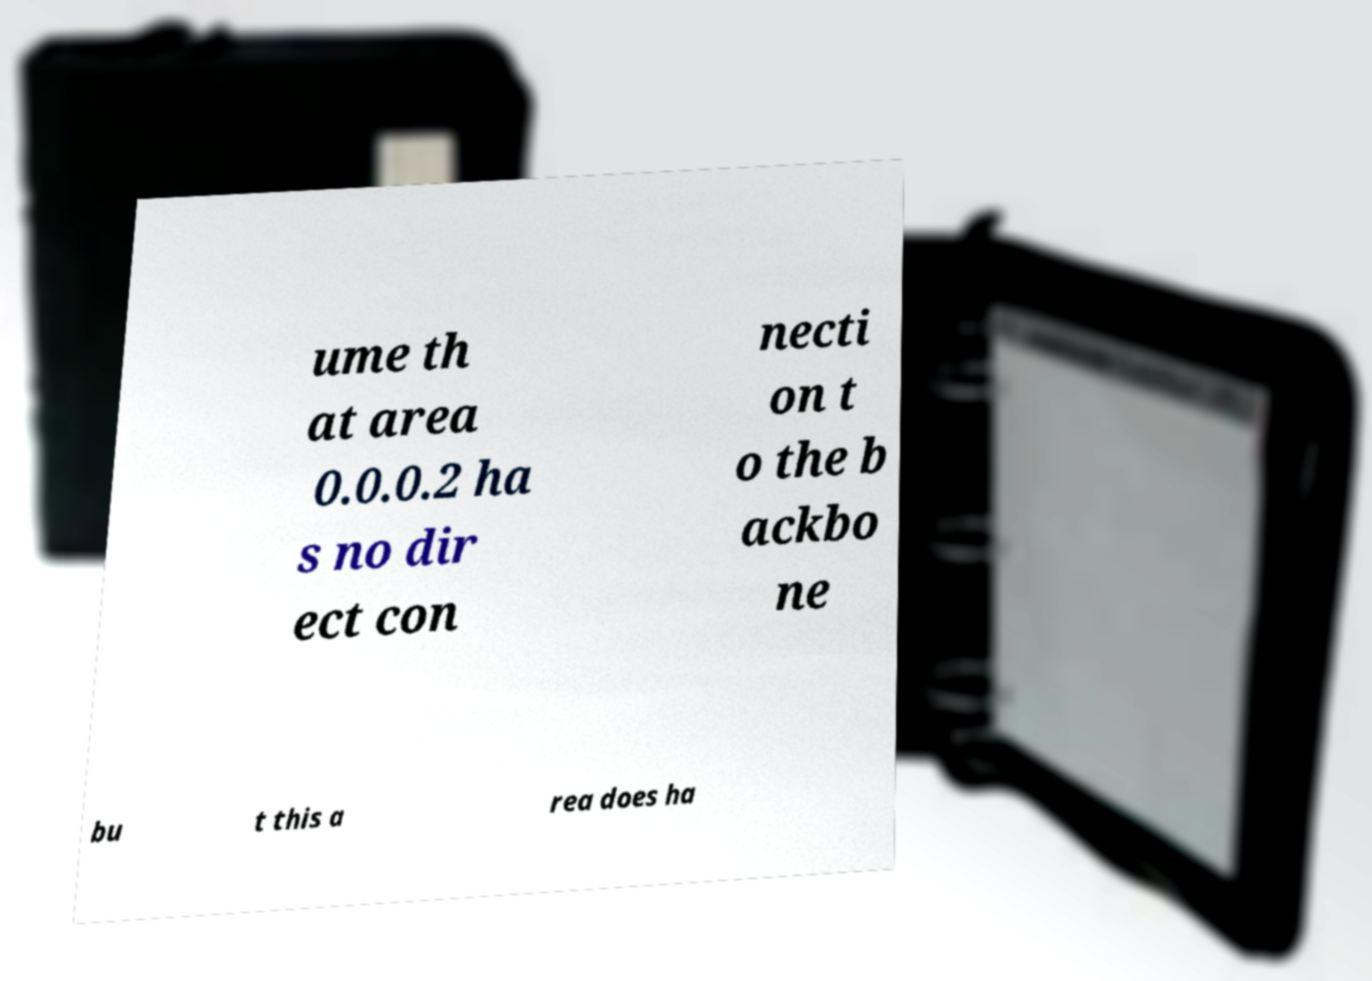Please read and relay the text visible in this image. What does it say? ume th at area 0.0.0.2 ha s no dir ect con necti on t o the b ackbo ne bu t this a rea does ha 